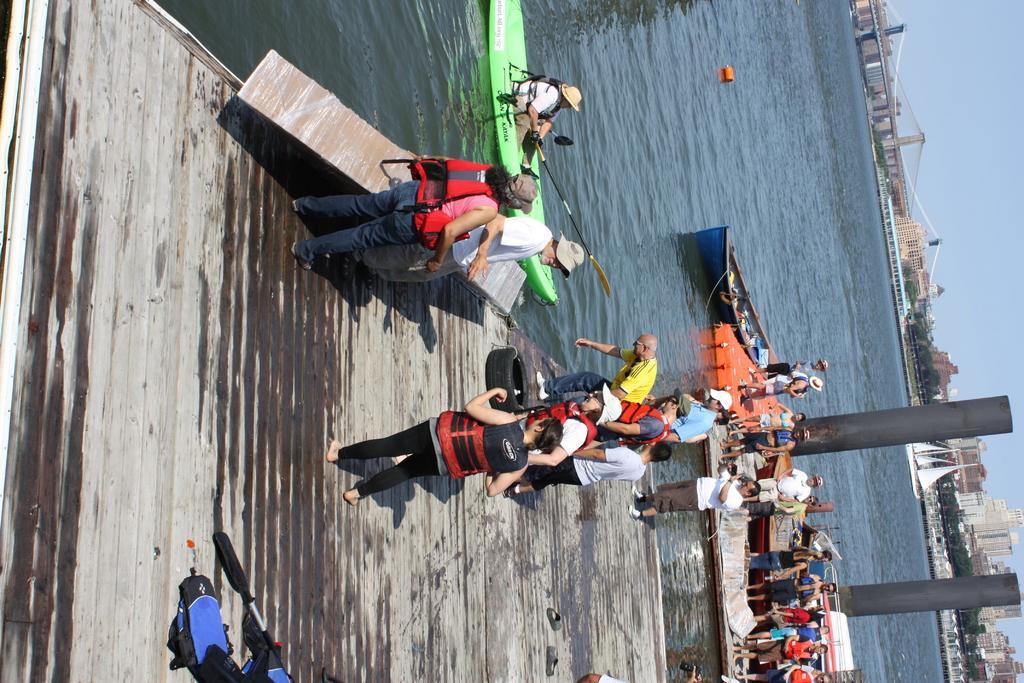Can you describe this image briefly? In this image I can see few people are wearing jackets and few are standing. They are in different color. I can see few boats. Back I can see bridge,trees and buildings. The sky is in blue color. We can see water. 